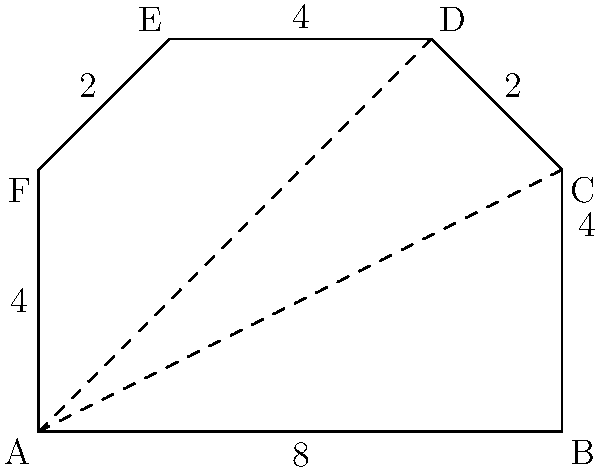As a track athlete, you're tasked with estimating the area of an irregularly shaped running course. The course is represented by the figure above, where all measurements are in meters. Divide the shape into a rectangle and two triangles to estimate its total area. What is your estimate in square meters? Let's break this down step-by-step:

1) First, we can divide the shape into a rectangle (ABCF) and two triangles (CDE and ADF).

2) For the rectangle ABCF:
   Length = 8 m, Width = 4 m
   Area of rectangle = $8 \times 4 = 32$ m²

3) For triangle CDE:
   Base = 2 m, Height = 2 m
   Area of CDE = $\frac{1}{2} \times 2 \times 2 = 2$ m²

4) For triangle ADF:
   Base = 6 m, Height = 2 m
   Area of ADF = $\frac{1}{2} \times 6 \times 2 = 6$ m²

5) Total estimated area:
   $32 + 2 + 6 = 40$ m²

Therefore, the estimated area of the running course is 40 square meters.
Answer: 40 m² 